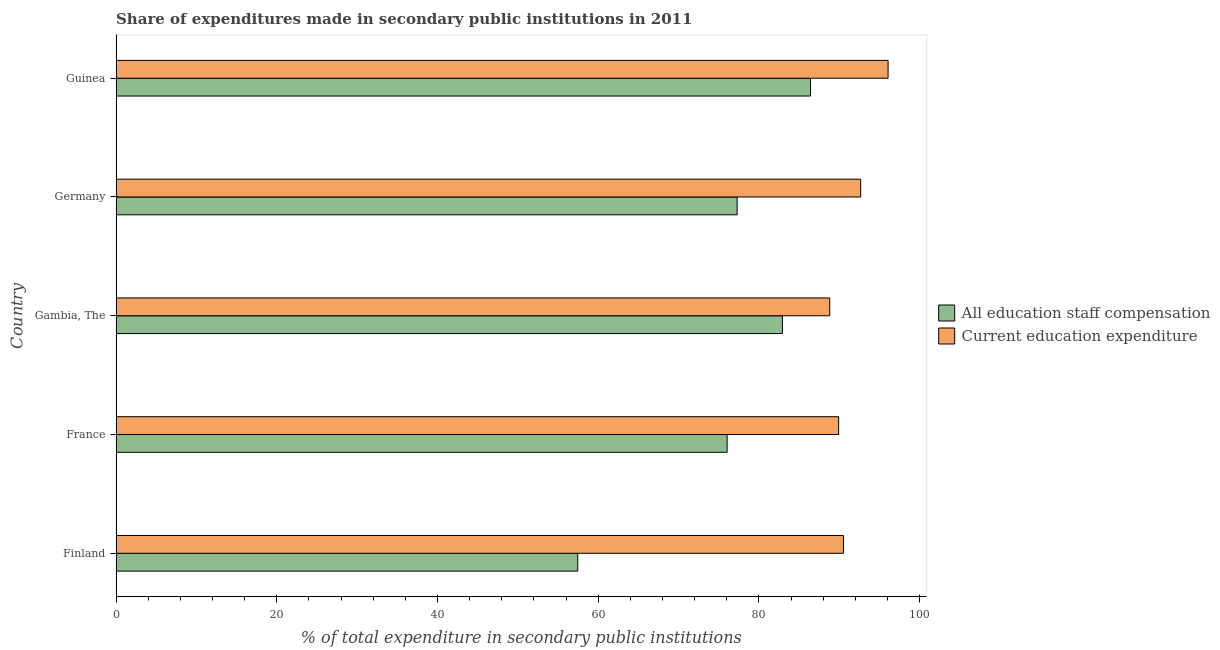How many bars are there on the 5th tick from the top?
Provide a short and direct response. 2. How many bars are there on the 3rd tick from the bottom?
Your answer should be compact. 2. What is the label of the 3rd group of bars from the top?
Provide a succinct answer. Gambia, The. In how many cases, is the number of bars for a given country not equal to the number of legend labels?
Offer a terse response. 0. What is the expenditure in staff compensation in Gambia, The?
Provide a short and direct response. 82.92. Across all countries, what is the maximum expenditure in education?
Make the answer very short. 96.07. Across all countries, what is the minimum expenditure in staff compensation?
Provide a succinct answer. 57.45. In which country was the expenditure in education maximum?
Provide a short and direct response. Guinea. In which country was the expenditure in education minimum?
Provide a short and direct response. Gambia, The. What is the total expenditure in staff compensation in the graph?
Keep it short and to the point. 380.11. What is the difference between the expenditure in education in Finland and that in Germany?
Provide a succinct answer. -2.15. What is the difference between the expenditure in staff compensation in Guinea and the expenditure in education in France?
Your response must be concise. -3.5. What is the average expenditure in education per country?
Offer a very short reply. 91.59. What is the difference between the expenditure in staff compensation and expenditure in education in Gambia, The?
Offer a terse response. -5.89. In how many countries, is the expenditure in education greater than 68 %?
Give a very brief answer. 5. What is the ratio of the expenditure in staff compensation in Finland to that in Gambia, The?
Your response must be concise. 0.69. Is the expenditure in staff compensation in Gambia, The less than that in Germany?
Your answer should be compact. No. What is the difference between the highest and the second highest expenditure in staff compensation?
Offer a very short reply. 3.5. What is the difference between the highest and the lowest expenditure in education?
Provide a short and direct response. 7.26. In how many countries, is the expenditure in staff compensation greater than the average expenditure in staff compensation taken over all countries?
Offer a very short reply. 4. Is the sum of the expenditure in staff compensation in France and Germany greater than the maximum expenditure in education across all countries?
Give a very brief answer. Yes. What does the 1st bar from the top in France represents?
Offer a terse response. Current education expenditure. What does the 1st bar from the bottom in France represents?
Your answer should be very brief. All education staff compensation. How many countries are there in the graph?
Keep it short and to the point. 5. Where does the legend appear in the graph?
Make the answer very short. Center right. How many legend labels are there?
Offer a very short reply. 2. What is the title of the graph?
Your answer should be compact. Share of expenditures made in secondary public institutions in 2011. What is the label or title of the X-axis?
Provide a short and direct response. % of total expenditure in secondary public institutions. What is the label or title of the Y-axis?
Offer a terse response. Country. What is the % of total expenditure in secondary public institutions in All education staff compensation in Finland?
Provide a succinct answer. 57.45. What is the % of total expenditure in secondary public institutions of Current education expenditure in Finland?
Your answer should be compact. 90.51. What is the % of total expenditure in secondary public institutions of All education staff compensation in France?
Offer a terse response. 76.04. What is the % of total expenditure in secondary public institutions in Current education expenditure in France?
Provide a short and direct response. 89.92. What is the % of total expenditure in secondary public institutions of All education staff compensation in Gambia, The?
Provide a short and direct response. 82.92. What is the % of total expenditure in secondary public institutions in Current education expenditure in Gambia, The?
Your answer should be compact. 88.81. What is the % of total expenditure in secondary public institutions in All education staff compensation in Germany?
Make the answer very short. 77.28. What is the % of total expenditure in secondary public institutions in Current education expenditure in Germany?
Your answer should be compact. 92.66. What is the % of total expenditure in secondary public institutions of All education staff compensation in Guinea?
Offer a very short reply. 86.42. What is the % of total expenditure in secondary public institutions in Current education expenditure in Guinea?
Your answer should be compact. 96.07. Across all countries, what is the maximum % of total expenditure in secondary public institutions in All education staff compensation?
Your response must be concise. 86.42. Across all countries, what is the maximum % of total expenditure in secondary public institutions in Current education expenditure?
Ensure brevity in your answer.  96.07. Across all countries, what is the minimum % of total expenditure in secondary public institutions of All education staff compensation?
Your answer should be very brief. 57.45. Across all countries, what is the minimum % of total expenditure in secondary public institutions in Current education expenditure?
Your answer should be very brief. 88.81. What is the total % of total expenditure in secondary public institutions in All education staff compensation in the graph?
Give a very brief answer. 380.11. What is the total % of total expenditure in secondary public institutions of Current education expenditure in the graph?
Provide a succinct answer. 457.97. What is the difference between the % of total expenditure in secondary public institutions of All education staff compensation in Finland and that in France?
Offer a very short reply. -18.59. What is the difference between the % of total expenditure in secondary public institutions of Current education expenditure in Finland and that in France?
Your answer should be very brief. 0.6. What is the difference between the % of total expenditure in secondary public institutions in All education staff compensation in Finland and that in Gambia, The?
Ensure brevity in your answer.  -25.47. What is the difference between the % of total expenditure in secondary public institutions of Current education expenditure in Finland and that in Gambia, The?
Give a very brief answer. 1.71. What is the difference between the % of total expenditure in secondary public institutions in All education staff compensation in Finland and that in Germany?
Your answer should be very brief. -19.83. What is the difference between the % of total expenditure in secondary public institutions in Current education expenditure in Finland and that in Germany?
Provide a short and direct response. -2.15. What is the difference between the % of total expenditure in secondary public institutions of All education staff compensation in Finland and that in Guinea?
Ensure brevity in your answer.  -28.97. What is the difference between the % of total expenditure in secondary public institutions of Current education expenditure in Finland and that in Guinea?
Provide a succinct answer. -5.56. What is the difference between the % of total expenditure in secondary public institutions of All education staff compensation in France and that in Gambia, The?
Your answer should be compact. -6.88. What is the difference between the % of total expenditure in secondary public institutions in Current education expenditure in France and that in Gambia, The?
Your answer should be compact. 1.11. What is the difference between the % of total expenditure in secondary public institutions in All education staff compensation in France and that in Germany?
Your answer should be compact. -1.24. What is the difference between the % of total expenditure in secondary public institutions of Current education expenditure in France and that in Germany?
Offer a terse response. -2.74. What is the difference between the % of total expenditure in secondary public institutions of All education staff compensation in France and that in Guinea?
Give a very brief answer. -10.38. What is the difference between the % of total expenditure in secondary public institutions of Current education expenditure in France and that in Guinea?
Make the answer very short. -6.15. What is the difference between the % of total expenditure in secondary public institutions of All education staff compensation in Gambia, The and that in Germany?
Your answer should be very brief. 5.64. What is the difference between the % of total expenditure in secondary public institutions of Current education expenditure in Gambia, The and that in Germany?
Give a very brief answer. -3.85. What is the difference between the % of total expenditure in secondary public institutions in All education staff compensation in Gambia, The and that in Guinea?
Keep it short and to the point. -3.5. What is the difference between the % of total expenditure in secondary public institutions in Current education expenditure in Gambia, The and that in Guinea?
Give a very brief answer. -7.26. What is the difference between the % of total expenditure in secondary public institutions in All education staff compensation in Germany and that in Guinea?
Your answer should be very brief. -9.13. What is the difference between the % of total expenditure in secondary public institutions of Current education expenditure in Germany and that in Guinea?
Provide a short and direct response. -3.41. What is the difference between the % of total expenditure in secondary public institutions in All education staff compensation in Finland and the % of total expenditure in secondary public institutions in Current education expenditure in France?
Provide a short and direct response. -32.47. What is the difference between the % of total expenditure in secondary public institutions in All education staff compensation in Finland and the % of total expenditure in secondary public institutions in Current education expenditure in Gambia, The?
Make the answer very short. -31.36. What is the difference between the % of total expenditure in secondary public institutions in All education staff compensation in Finland and the % of total expenditure in secondary public institutions in Current education expenditure in Germany?
Your response must be concise. -35.21. What is the difference between the % of total expenditure in secondary public institutions in All education staff compensation in Finland and the % of total expenditure in secondary public institutions in Current education expenditure in Guinea?
Offer a very short reply. -38.62. What is the difference between the % of total expenditure in secondary public institutions in All education staff compensation in France and the % of total expenditure in secondary public institutions in Current education expenditure in Gambia, The?
Your response must be concise. -12.77. What is the difference between the % of total expenditure in secondary public institutions in All education staff compensation in France and the % of total expenditure in secondary public institutions in Current education expenditure in Germany?
Your answer should be compact. -16.62. What is the difference between the % of total expenditure in secondary public institutions in All education staff compensation in France and the % of total expenditure in secondary public institutions in Current education expenditure in Guinea?
Provide a succinct answer. -20.03. What is the difference between the % of total expenditure in secondary public institutions in All education staff compensation in Gambia, The and the % of total expenditure in secondary public institutions in Current education expenditure in Germany?
Offer a very short reply. -9.74. What is the difference between the % of total expenditure in secondary public institutions of All education staff compensation in Gambia, The and the % of total expenditure in secondary public institutions of Current education expenditure in Guinea?
Offer a terse response. -13.15. What is the difference between the % of total expenditure in secondary public institutions of All education staff compensation in Germany and the % of total expenditure in secondary public institutions of Current education expenditure in Guinea?
Provide a succinct answer. -18.79. What is the average % of total expenditure in secondary public institutions in All education staff compensation per country?
Your answer should be compact. 76.02. What is the average % of total expenditure in secondary public institutions of Current education expenditure per country?
Keep it short and to the point. 91.59. What is the difference between the % of total expenditure in secondary public institutions in All education staff compensation and % of total expenditure in secondary public institutions in Current education expenditure in Finland?
Make the answer very short. -33.06. What is the difference between the % of total expenditure in secondary public institutions of All education staff compensation and % of total expenditure in secondary public institutions of Current education expenditure in France?
Your response must be concise. -13.88. What is the difference between the % of total expenditure in secondary public institutions in All education staff compensation and % of total expenditure in secondary public institutions in Current education expenditure in Gambia, The?
Keep it short and to the point. -5.89. What is the difference between the % of total expenditure in secondary public institutions of All education staff compensation and % of total expenditure in secondary public institutions of Current education expenditure in Germany?
Give a very brief answer. -15.38. What is the difference between the % of total expenditure in secondary public institutions in All education staff compensation and % of total expenditure in secondary public institutions in Current education expenditure in Guinea?
Your answer should be very brief. -9.66. What is the ratio of the % of total expenditure in secondary public institutions of All education staff compensation in Finland to that in France?
Your response must be concise. 0.76. What is the ratio of the % of total expenditure in secondary public institutions in Current education expenditure in Finland to that in France?
Ensure brevity in your answer.  1.01. What is the ratio of the % of total expenditure in secondary public institutions in All education staff compensation in Finland to that in Gambia, The?
Ensure brevity in your answer.  0.69. What is the ratio of the % of total expenditure in secondary public institutions in Current education expenditure in Finland to that in Gambia, The?
Give a very brief answer. 1.02. What is the ratio of the % of total expenditure in secondary public institutions in All education staff compensation in Finland to that in Germany?
Give a very brief answer. 0.74. What is the ratio of the % of total expenditure in secondary public institutions of Current education expenditure in Finland to that in Germany?
Your response must be concise. 0.98. What is the ratio of the % of total expenditure in secondary public institutions of All education staff compensation in Finland to that in Guinea?
Ensure brevity in your answer.  0.66. What is the ratio of the % of total expenditure in secondary public institutions in Current education expenditure in Finland to that in Guinea?
Keep it short and to the point. 0.94. What is the ratio of the % of total expenditure in secondary public institutions in All education staff compensation in France to that in Gambia, The?
Give a very brief answer. 0.92. What is the ratio of the % of total expenditure in secondary public institutions of Current education expenditure in France to that in Gambia, The?
Your answer should be very brief. 1.01. What is the ratio of the % of total expenditure in secondary public institutions in All education staff compensation in France to that in Germany?
Your answer should be compact. 0.98. What is the ratio of the % of total expenditure in secondary public institutions of Current education expenditure in France to that in Germany?
Keep it short and to the point. 0.97. What is the ratio of the % of total expenditure in secondary public institutions in All education staff compensation in France to that in Guinea?
Your response must be concise. 0.88. What is the ratio of the % of total expenditure in secondary public institutions in Current education expenditure in France to that in Guinea?
Give a very brief answer. 0.94. What is the ratio of the % of total expenditure in secondary public institutions in All education staff compensation in Gambia, The to that in Germany?
Your answer should be very brief. 1.07. What is the ratio of the % of total expenditure in secondary public institutions of Current education expenditure in Gambia, The to that in Germany?
Make the answer very short. 0.96. What is the ratio of the % of total expenditure in secondary public institutions of All education staff compensation in Gambia, The to that in Guinea?
Make the answer very short. 0.96. What is the ratio of the % of total expenditure in secondary public institutions in Current education expenditure in Gambia, The to that in Guinea?
Offer a very short reply. 0.92. What is the ratio of the % of total expenditure in secondary public institutions of All education staff compensation in Germany to that in Guinea?
Keep it short and to the point. 0.89. What is the ratio of the % of total expenditure in secondary public institutions in Current education expenditure in Germany to that in Guinea?
Ensure brevity in your answer.  0.96. What is the difference between the highest and the second highest % of total expenditure in secondary public institutions in All education staff compensation?
Offer a very short reply. 3.5. What is the difference between the highest and the second highest % of total expenditure in secondary public institutions of Current education expenditure?
Keep it short and to the point. 3.41. What is the difference between the highest and the lowest % of total expenditure in secondary public institutions of All education staff compensation?
Give a very brief answer. 28.97. What is the difference between the highest and the lowest % of total expenditure in secondary public institutions in Current education expenditure?
Your answer should be compact. 7.26. 